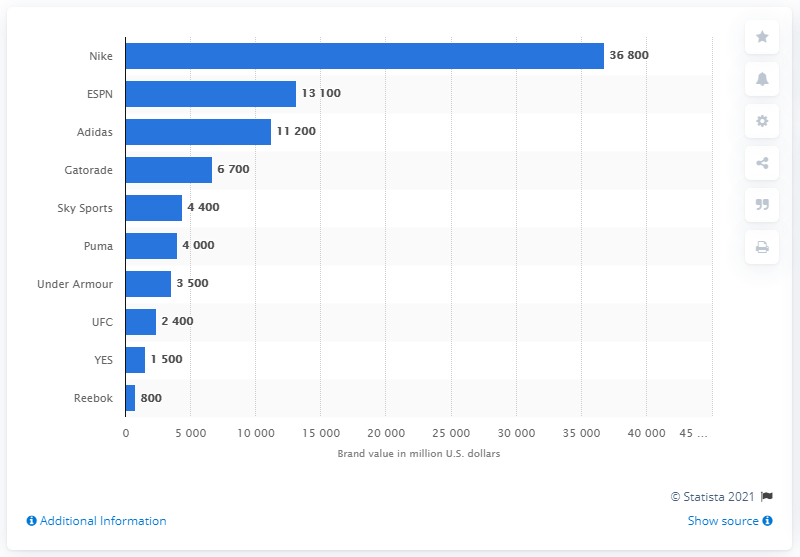Mention a couple of crucial points in this snapshot. In 2019, ESPN's brand value in the United States was estimated to be approximately 13100. In 2019, Nike was recognized as the most valuable sports business brand in the world. In 2019, Nike's brand value in the United States was 36,800 U.S. dollars. 